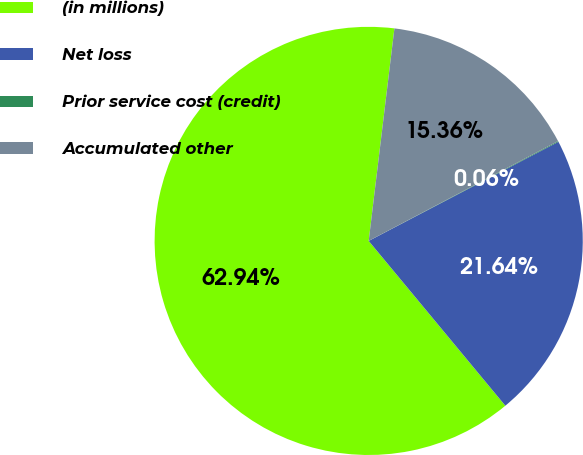Convert chart to OTSL. <chart><loc_0><loc_0><loc_500><loc_500><pie_chart><fcel>(in millions)<fcel>Net loss<fcel>Prior service cost (credit)<fcel>Accumulated other<nl><fcel>62.93%<fcel>21.64%<fcel>0.06%<fcel>15.36%<nl></chart> 